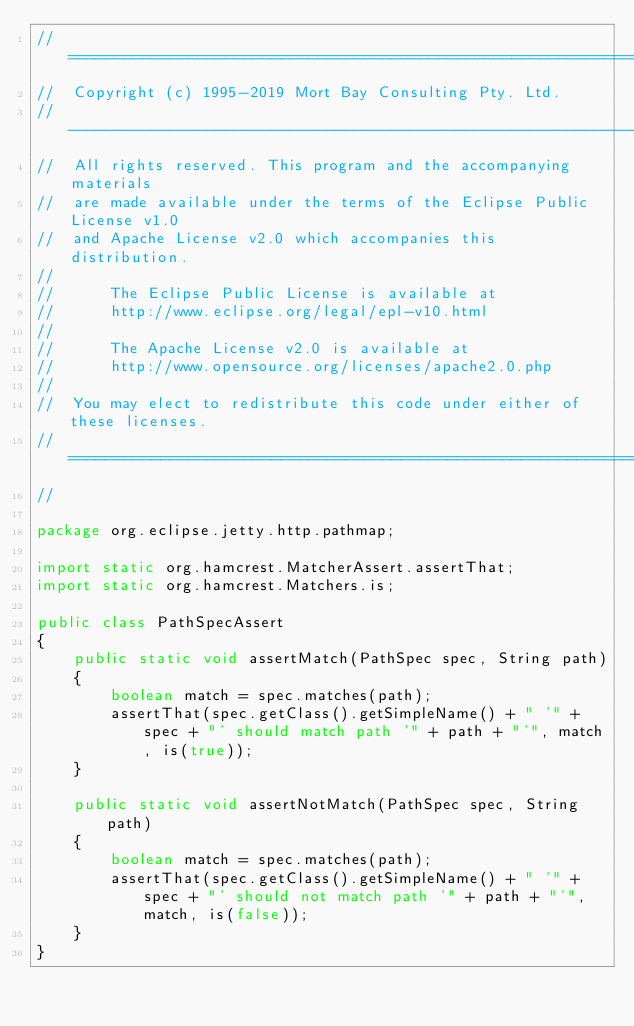Convert code to text. <code><loc_0><loc_0><loc_500><loc_500><_Java_>//  ========================================================================
//  Copyright (c) 1995-2019 Mort Bay Consulting Pty. Ltd.
//  ------------------------------------------------------------------------
//  All rights reserved. This program and the accompanying materials
//  are made available under the terms of the Eclipse Public License v1.0
//  and Apache License v2.0 which accompanies this distribution.
//
//      The Eclipse Public License is available at
//      http://www.eclipse.org/legal/epl-v10.html
//
//      The Apache License v2.0 is available at
//      http://www.opensource.org/licenses/apache2.0.php
//
//  You may elect to redistribute this code under either of these licenses.
//  ========================================================================
//

package org.eclipse.jetty.http.pathmap;

import static org.hamcrest.MatcherAssert.assertThat;
import static org.hamcrest.Matchers.is;

public class PathSpecAssert
{
    public static void assertMatch(PathSpec spec, String path)
    {
        boolean match = spec.matches(path);
        assertThat(spec.getClass().getSimpleName() + " '" + spec + "' should match path '" + path + "'", match, is(true));
    }

    public static void assertNotMatch(PathSpec spec, String path)
    {
        boolean match = spec.matches(path);
        assertThat(spec.getClass().getSimpleName() + " '" + spec + "' should not match path '" + path + "'", match, is(false));
    }
}
</code> 